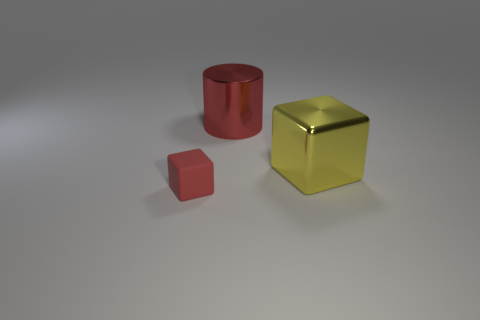Add 1 big purple shiny cylinders. How many objects exist? 4 Subtract all cubes. How many objects are left? 1 Subtract all small blue cubes. Subtract all large red objects. How many objects are left? 2 Add 3 blocks. How many blocks are left? 5 Add 2 small blue cubes. How many small blue cubes exist? 2 Subtract 0 brown cylinders. How many objects are left? 3 